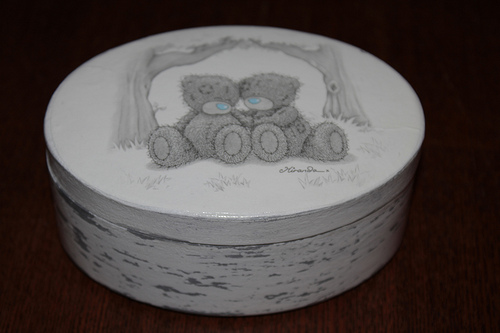<image>
Can you confirm if the bear is on the tin? Yes. Looking at the image, I can see the bear is positioned on top of the tin, with the tin providing support. 